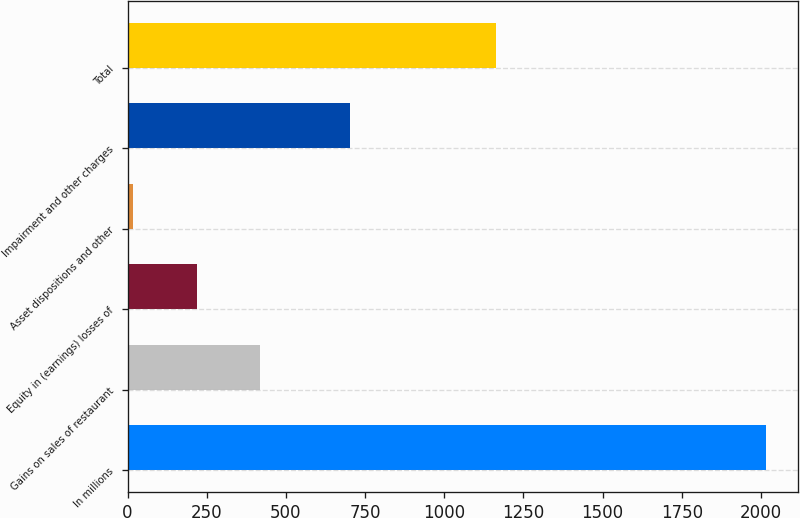<chart> <loc_0><loc_0><loc_500><loc_500><bar_chart><fcel>In millions<fcel>Gains on sales of restaurant<fcel>Equity in (earnings) losses of<fcel>Asset dispositions and other<fcel>Impairment and other charges<fcel>Total<nl><fcel>2017<fcel>418.36<fcel>218.53<fcel>18.7<fcel>702.8<fcel>1163.2<nl></chart> 